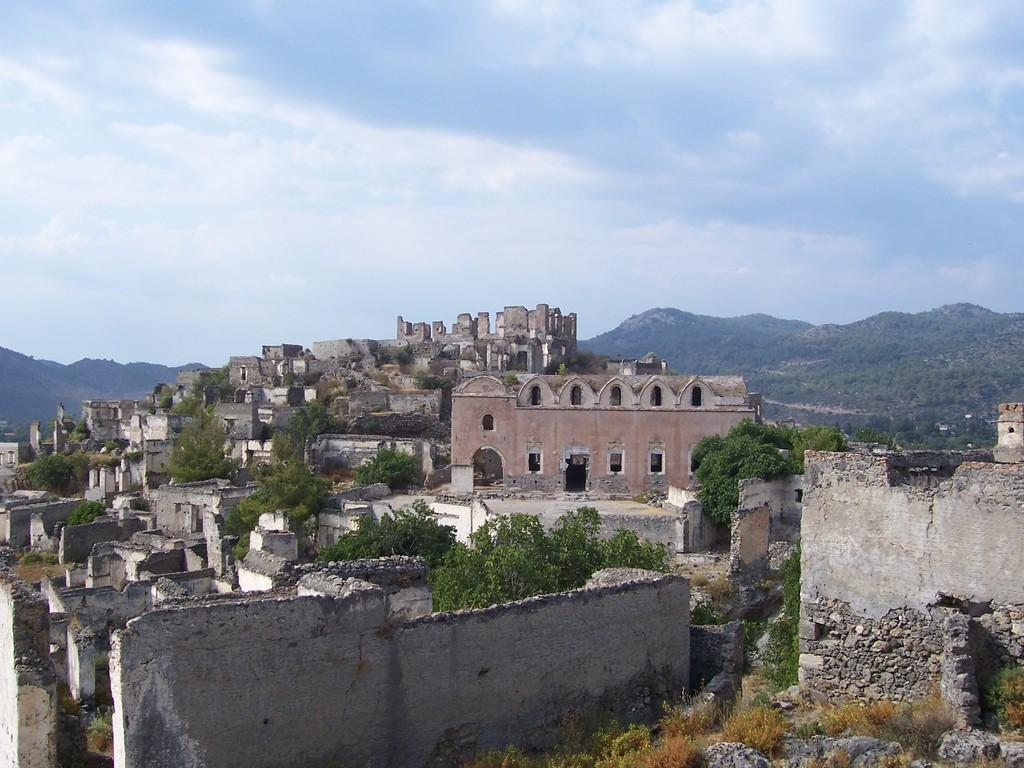What type of structures can be seen in the image? There are houses in the image. What type of vegetation is present in the image? There are trees and grass in the image. What type of natural features can be seen in the image? There are rocks and hills in the image. What is visible in the sky in the image? The sky is visible in the image, and clouds are present. How does the beggar balance on the rock in the image? There is no beggar present in the image; it features houses, trees, grass, rocks, hills, sky, and clouds. What type of surprise can be seen in the image? There is no surprise present in the image; it is a natural scene with houses, trees, grass, rocks, hills, sky, and clouds. 